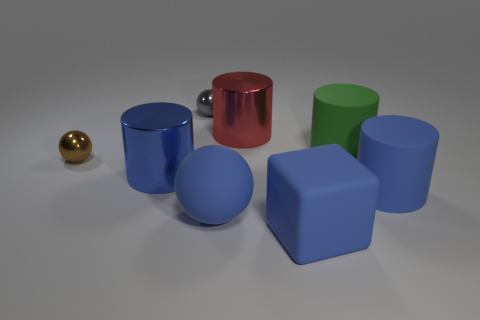Subtract all blue metal cylinders. How many cylinders are left? 3 Add 2 rubber cubes. How many objects exist? 10 Subtract all blue balls. How many balls are left? 2 Add 7 large red objects. How many large red objects are left? 8 Add 8 small balls. How many small balls exist? 10 Subtract 2 blue cylinders. How many objects are left? 6 Subtract all cubes. How many objects are left? 7 Subtract 2 balls. How many balls are left? 1 Subtract all gray balls. Subtract all yellow cylinders. How many balls are left? 2 Subtract all brown cylinders. How many blue spheres are left? 1 